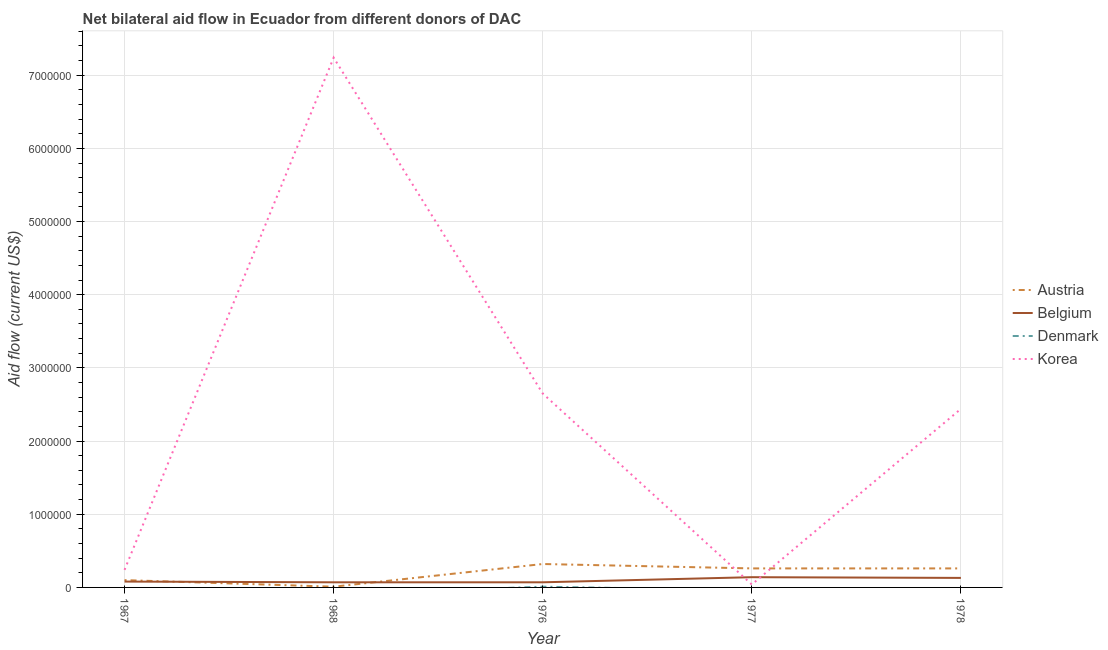How many different coloured lines are there?
Your answer should be very brief. 4. Does the line corresponding to amount of aid given by belgium intersect with the line corresponding to amount of aid given by austria?
Ensure brevity in your answer.  Yes. Is the number of lines equal to the number of legend labels?
Your answer should be compact. No. What is the amount of aid given by denmark in 1978?
Your answer should be very brief. 0. Across all years, what is the maximum amount of aid given by denmark?
Keep it short and to the point. 10000. Across all years, what is the minimum amount of aid given by austria?
Offer a very short reply. 10000. In which year was the amount of aid given by belgium maximum?
Make the answer very short. 1977. What is the total amount of aid given by denmark in the graph?
Your answer should be very brief. 10000. What is the difference between the amount of aid given by austria in 1967 and that in 1977?
Your answer should be very brief. -1.60e+05. What is the difference between the amount of aid given by korea in 1967 and the amount of aid given by belgium in 1968?
Your answer should be very brief. 1.70e+05. In the year 1977, what is the difference between the amount of aid given by belgium and amount of aid given by austria?
Your response must be concise. -1.20e+05. What is the ratio of the amount of aid given by belgium in 1967 to that in 1977?
Make the answer very short. 0.57. What is the difference between the highest and the second highest amount of aid given by korea?
Ensure brevity in your answer.  4.59e+06. What is the difference between the highest and the lowest amount of aid given by belgium?
Your response must be concise. 7.00e+04. Is it the case that in every year, the sum of the amount of aid given by austria and amount of aid given by belgium is greater than the amount of aid given by denmark?
Offer a very short reply. Yes. Does the amount of aid given by korea monotonically increase over the years?
Keep it short and to the point. No. Is the amount of aid given by denmark strictly greater than the amount of aid given by belgium over the years?
Offer a terse response. No. How many years are there in the graph?
Your response must be concise. 5. Does the graph contain any zero values?
Your answer should be very brief. Yes. Where does the legend appear in the graph?
Provide a succinct answer. Center right. What is the title of the graph?
Offer a terse response. Net bilateral aid flow in Ecuador from different donors of DAC. What is the label or title of the X-axis?
Your answer should be compact. Year. What is the label or title of the Y-axis?
Your answer should be compact. Aid flow (current US$). What is the Aid flow (current US$) in Austria in 1967?
Offer a very short reply. 1.00e+05. What is the Aid flow (current US$) in Belgium in 1967?
Ensure brevity in your answer.  8.00e+04. What is the Aid flow (current US$) in Denmark in 1967?
Your answer should be very brief. 0. What is the Aid flow (current US$) of Austria in 1968?
Ensure brevity in your answer.  10000. What is the Aid flow (current US$) of Belgium in 1968?
Your answer should be very brief. 7.00e+04. What is the Aid flow (current US$) of Denmark in 1968?
Your answer should be very brief. 0. What is the Aid flow (current US$) in Korea in 1968?
Keep it short and to the point. 7.24e+06. What is the Aid flow (current US$) in Austria in 1976?
Offer a terse response. 3.20e+05. What is the Aid flow (current US$) in Belgium in 1976?
Make the answer very short. 7.00e+04. What is the Aid flow (current US$) of Denmark in 1976?
Offer a very short reply. 10000. What is the Aid flow (current US$) in Korea in 1976?
Ensure brevity in your answer.  2.65e+06. What is the Aid flow (current US$) of Austria in 1978?
Offer a very short reply. 2.60e+05. What is the Aid flow (current US$) of Korea in 1978?
Keep it short and to the point. 2.44e+06. Across all years, what is the maximum Aid flow (current US$) in Austria?
Your answer should be compact. 3.20e+05. Across all years, what is the maximum Aid flow (current US$) of Denmark?
Provide a succinct answer. 10000. Across all years, what is the maximum Aid flow (current US$) of Korea?
Provide a succinct answer. 7.24e+06. Across all years, what is the minimum Aid flow (current US$) in Korea?
Your answer should be compact. 4.00e+04. What is the total Aid flow (current US$) in Austria in the graph?
Give a very brief answer. 9.50e+05. What is the total Aid flow (current US$) in Denmark in the graph?
Keep it short and to the point. 10000. What is the total Aid flow (current US$) of Korea in the graph?
Provide a short and direct response. 1.26e+07. What is the difference between the Aid flow (current US$) of Korea in 1967 and that in 1968?
Offer a very short reply. -7.00e+06. What is the difference between the Aid flow (current US$) of Austria in 1967 and that in 1976?
Offer a terse response. -2.20e+05. What is the difference between the Aid flow (current US$) of Belgium in 1967 and that in 1976?
Offer a very short reply. 10000. What is the difference between the Aid flow (current US$) of Korea in 1967 and that in 1976?
Give a very brief answer. -2.41e+06. What is the difference between the Aid flow (current US$) of Korea in 1967 and that in 1977?
Give a very brief answer. 2.00e+05. What is the difference between the Aid flow (current US$) in Belgium in 1967 and that in 1978?
Keep it short and to the point. -5.00e+04. What is the difference between the Aid flow (current US$) in Korea in 1967 and that in 1978?
Give a very brief answer. -2.20e+06. What is the difference between the Aid flow (current US$) in Austria in 1968 and that in 1976?
Keep it short and to the point. -3.10e+05. What is the difference between the Aid flow (current US$) in Korea in 1968 and that in 1976?
Keep it short and to the point. 4.59e+06. What is the difference between the Aid flow (current US$) of Korea in 1968 and that in 1977?
Make the answer very short. 7.20e+06. What is the difference between the Aid flow (current US$) in Belgium in 1968 and that in 1978?
Make the answer very short. -6.00e+04. What is the difference between the Aid flow (current US$) in Korea in 1968 and that in 1978?
Your response must be concise. 4.80e+06. What is the difference between the Aid flow (current US$) in Belgium in 1976 and that in 1977?
Your answer should be compact. -7.00e+04. What is the difference between the Aid flow (current US$) of Korea in 1976 and that in 1977?
Provide a short and direct response. 2.61e+06. What is the difference between the Aid flow (current US$) of Korea in 1976 and that in 1978?
Your response must be concise. 2.10e+05. What is the difference between the Aid flow (current US$) of Korea in 1977 and that in 1978?
Provide a succinct answer. -2.40e+06. What is the difference between the Aid flow (current US$) in Austria in 1967 and the Aid flow (current US$) in Korea in 1968?
Your answer should be compact. -7.14e+06. What is the difference between the Aid flow (current US$) in Belgium in 1967 and the Aid flow (current US$) in Korea in 1968?
Your answer should be compact. -7.16e+06. What is the difference between the Aid flow (current US$) of Austria in 1967 and the Aid flow (current US$) of Denmark in 1976?
Offer a terse response. 9.00e+04. What is the difference between the Aid flow (current US$) in Austria in 1967 and the Aid flow (current US$) in Korea in 1976?
Ensure brevity in your answer.  -2.55e+06. What is the difference between the Aid flow (current US$) of Belgium in 1967 and the Aid flow (current US$) of Denmark in 1976?
Give a very brief answer. 7.00e+04. What is the difference between the Aid flow (current US$) of Belgium in 1967 and the Aid flow (current US$) of Korea in 1976?
Your answer should be compact. -2.57e+06. What is the difference between the Aid flow (current US$) of Austria in 1967 and the Aid flow (current US$) of Korea in 1977?
Make the answer very short. 6.00e+04. What is the difference between the Aid flow (current US$) in Belgium in 1967 and the Aid flow (current US$) in Korea in 1977?
Keep it short and to the point. 4.00e+04. What is the difference between the Aid flow (current US$) in Austria in 1967 and the Aid flow (current US$) in Belgium in 1978?
Provide a succinct answer. -3.00e+04. What is the difference between the Aid flow (current US$) of Austria in 1967 and the Aid flow (current US$) of Korea in 1978?
Keep it short and to the point. -2.34e+06. What is the difference between the Aid flow (current US$) in Belgium in 1967 and the Aid flow (current US$) in Korea in 1978?
Your answer should be very brief. -2.36e+06. What is the difference between the Aid flow (current US$) of Austria in 1968 and the Aid flow (current US$) of Denmark in 1976?
Your response must be concise. 0. What is the difference between the Aid flow (current US$) of Austria in 1968 and the Aid flow (current US$) of Korea in 1976?
Offer a very short reply. -2.64e+06. What is the difference between the Aid flow (current US$) of Belgium in 1968 and the Aid flow (current US$) of Korea in 1976?
Ensure brevity in your answer.  -2.58e+06. What is the difference between the Aid flow (current US$) of Austria in 1968 and the Aid flow (current US$) of Belgium in 1977?
Provide a short and direct response. -1.30e+05. What is the difference between the Aid flow (current US$) in Austria in 1968 and the Aid flow (current US$) in Belgium in 1978?
Offer a very short reply. -1.20e+05. What is the difference between the Aid flow (current US$) in Austria in 1968 and the Aid flow (current US$) in Korea in 1978?
Provide a succinct answer. -2.43e+06. What is the difference between the Aid flow (current US$) in Belgium in 1968 and the Aid flow (current US$) in Korea in 1978?
Keep it short and to the point. -2.37e+06. What is the difference between the Aid flow (current US$) of Belgium in 1976 and the Aid flow (current US$) of Korea in 1977?
Offer a very short reply. 3.00e+04. What is the difference between the Aid flow (current US$) in Denmark in 1976 and the Aid flow (current US$) in Korea in 1977?
Ensure brevity in your answer.  -3.00e+04. What is the difference between the Aid flow (current US$) in Austria in 1976 and the Aid flow (current US$) in Korea in 1978?
Keep it short and to the point. -2.12e+06. What is the difference between the Aid flow (current US$) in Belgium in 1976 and the Aid flow (current US$) in Korea in 1978?
Keep it short and to the point. -2.37e+06. What is the difference between the Aid flow (current US$) in Denmark in 1976 and the Aid flow (current US$) in Korea in 1978?
Keep it short and to the point. -2.43e+06. What is the difference between the Aid flow (current US$) in Austria in 1977 and the Aid flow (current US$) in Korea in 1978?
Provide a succinct answer. -2.18e+06. What is the difference between the Aid flow (current US$) of Belgium in 1977 and the Aid flow (current US$) of Korea in 1978?
Give a very brief answer. -2.30e+06. What is the average Aid flow (current US$) in Austria per year?
Your answer should be compact. 1.90e+05. What is the average Aid flow (current US$) in Belgium per year?
Provide a short and direct response. 9.80e+04. What is the average Aid flow (current US$) of Korea per year?
Keep it short and to the point. 2.52e+06. In the year 1967, what is the difference between the Aid flow (current US$) of Belgium and Aid flow (current US$) of Korea?
Offer a very short reply. -1.60e+05. In the year 1968, what is the difference between the Aid flow (current US$) of Austria and Aid flow (current US$) of Belgium?
Offer a very short reply. -6.00e+04. In the year 1968, what is the difference between the Aid flow (current US$) in Austria and Aid flow (current US$) in Korea?
Your answer should be very brief. -7.23e+06. In the year 1968, what is the difference between the Aid flow (current US$) in Belgium and Aid flow (current US$) in Korea?
Offer a terse response. -7.17e+06. In the year 1976, what is the difference between the Aid flow (current US$) of Austria and Aid flow (current US$) of Denmark?
Provide a short and direct response. 3.10e+05. In the year 1976, what is the difference between the Aid flow (current US$) of Austria and Aid flow (current US$) of Korea?
Ensure brevity in your answer.  -2.33e+06. In the year 1976, what is the difference between the Aid flow (current US$) in Belgium and Aid flow (current US$) in Korea?
Ensure brevity in your answer.  -2.58e+06. In the year 1976, what is the difference between the Aid flow (current US$) of Denmark and Aid flow (current US$) of Korea?
Your response must be concise. -2.64e+06. In the year 1977, what is the difference between the Aid flow (current US$) of Austria and Aid flow (current US$) of Belgium?
Ensure brevity in your answer.  1.20e+05. In the year 1977, what is the difference between the Aid flow (current US$) of Austria and Aid flow (current US$) of Korea?
Give a very brief answer. 2.20e+05. In the year 1978, what is the difference between the Aid flow (current US$) in Austria and Aid flow (current US$) in Belgium?
Your response must be concise. 1.30e+05. In the year 1978, what is the difference between the Aid flow (current US$) of Austria and Aid flow (current US$) of Korea?
Keep it short and to the point. -2.18e+06. In the year 1978, what is the difference between the Aid flow (current US$) in Belgium and Aid flow (current US$) in Korea?
Keep it short and to the point. -2.31e+06. What is the ratio of the Aid flow (current US$) of Korea in 1967 to that in 1968?
Ensure brevity in your answer.  0.03. What is the ratio of the Aid flow (current US$) of Austria in 1967 to that in 1976?
Provide a short and direct response. 0.31. What is the ratio of the Aid flow (current US$) in Belgium in 1967 to that in 1976?
Your answer should be compact. 1.14. What is the ratio of the Aid flow (current US$) of Korea in 1967 to that in 1976?
Give a very brief answer. 0.09. What is the ratio of the Aid flow (current US$) in Austria in 1967 to that in 1977?
Provide a short and direct response. 0.38. What is the ratio of the Aid flow (current US$) in Austria in 1967 to that in 1978?
Your answer should be compact. 0.38. What is the ratio of the Aid flow (current US$) of Belgium in 1967 to that in 1978?
Give a very brief answer. 0.62. What is the ratio of the Aid flow (current US$) of Korea in 1967 to that in 1978?
Offer a terse response. 0.1. What is the ratio of the Aid flow (current US$) of Austria in 1968 to that in 1976?
Ensure brevity in your answer.  0.03. What is the ratio of the Aid flow (current US$) in Korea in 1968 to that in 1976?
Offer a terse response. 2.73. What is the ratio of the Aid flow (current US$) in Austria in 1968 to that in 1977?
Provide a succinct answer. 0.04. What is the ratio of the Aid flow (current US$) of Korea in 1968 to that in 1977?
Give a very brief answer. 181. What is the ratio of the Aid flow (current US$) in Austria in 1968 to that in 1978?
Offer a terse response. 0.04. What is the ratio of the Aid flow (current US$) in Belgium in 1968 to that in 1978?
Keep it short and to the point. 0.54. What is the ratio of the Aid flow (current US$) in Korea in 1968 to that in 1978?
Offer a terse response. 2.97. What is the ratio of the Aid flow (current US$) in Austria in 1976 to that in 1977?
Ensure brevity in your answer.  1.23. What is the ratio of the Aid flow (current US$) of Belgium in 1976 to that in 1977?
Make the answer very short. 0.5. What is the ratio of the Aid flow (current US$) of Korea in 1976 to that in 1977?
Make the answer very short. 66.25. What is the ratio of the Aid flow (current US$) in Austria in 1976 to that in 1978?
Offer a very short reply. 1.23. What is the ratio of the Aid flow (current US$) in Belgium in 1976 to that in 1978?
Provide a succinct answer. 0.54. What is the ratio of the Aid flow (current US$) of Korea in 1976 to that in 1978?
Make the answer very short. 1.09. What is the ratio of the Aid flow (current US$) in Belgium in 1977 to that in 1978?
Ensure brevity in your answer.  1.08. What is the ratio of the Aid flow (current US$) of Korea in 1977 to that in 1978?
Provide a succinct answer. 0.02. What is the difference between the highest and the second highest Aid flow (current US$) of Austria?
Make the answer very short. 6.00e+04. What is the difference between the highest and the second highest Aid flow (current US$) in Korea?
Keep it short and to the point. 4.59e+06. What is the difference between the highest and the lowest Aid flow (current US$) in Belgium?
Offer a terse response. 7.00e+04. What is the difference between the highest and the lowest Aid flow (current US$) of Denmark?
Give a very brief answer. 10000. What is the difference between the highest and the lowest Aid flow (current US$) in Korea?
Your answer should be very brief. 7.20e+06. 